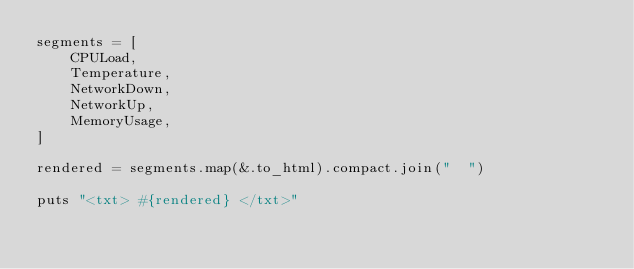Convert code to text. <code><loc_0><loc_0><loc_500><loc_500><_Crystal_>segments = [
    CPULoad,
    Temperature,
    NetworkDown,
    NetworkUp,
    MemoryUsage,
]

rendered = segments.map(&.to_html).compact.join("  ")

puts "<txt> #{rendered} </txt>"
</code> 